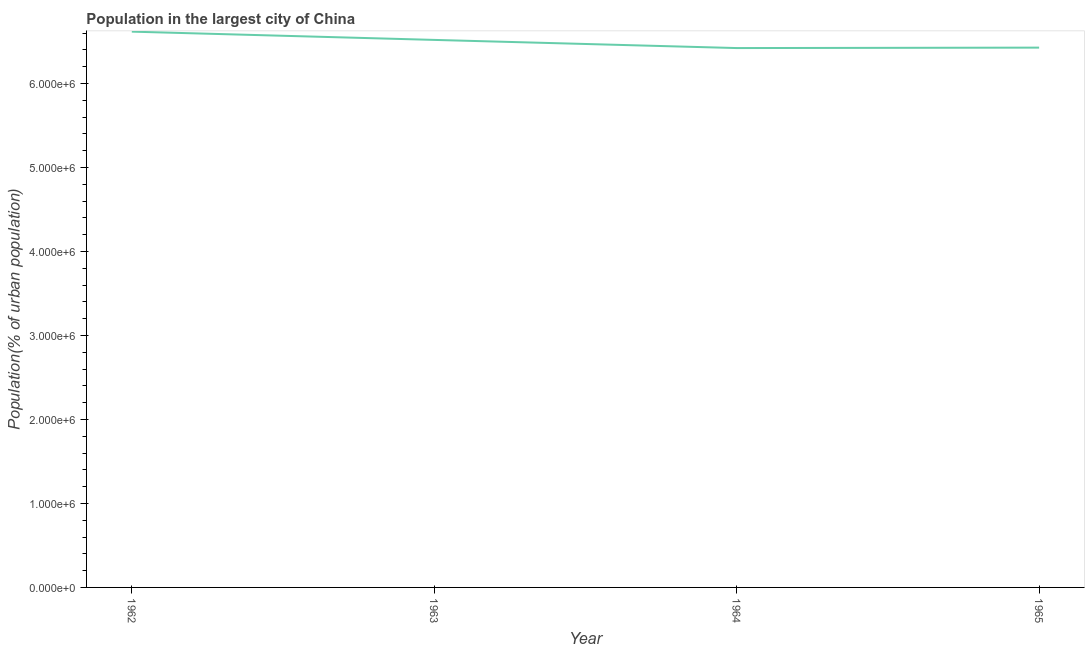What is the population in largest city in 1964?
Your response must be concise. 6.42e+06. Across all years, what is the maximum population in largest city?
Ensure brevity in your answer.  6.62e+06. Across all years, what is the minimum population in largest city?
Your response must be concise. 6.42e+06. In which year was the population in largest city minimum?
Your answer should be compact. 1964. What is the sum of the population in largest city?
Ensure brevity in your answer.  2.60e+07. What is the difference between the population in largest city in 1962 and 1963?
Make the answer very short. 9.84e+04. What is the average population in largest city per year?
Provide a succinct answer. 6.50e+06. What is the median population in largest city?
Ensure brevity in your answer.  6.47e+06. What is the ratio of the population in largest city in 1963 to that in 1965?
Ensure brevity in your answer.  1.01. Is the population in largest city in 1962 less than that in 1963?
Offer a terse response. No. Is the difference between the population in largest city in 1963 and 1964 greater than the difference between any two years?
Provide a succinct answer. No. What is the difference between the highest and the second highest population in largest city?
Offer a terse response. 9.84e+04. What is the difference between the highest and the lowest population in largest city?
Provide a succinct answer. 1.95e+05. In how many years, is the population in largest city greater than the average population in largest city taken over all years?
Offer a terse response. 2. How many lines are there?
Give a very brief answer. 1. How many years are there in the graph?
Provide a short and direct response. 4. What is the title of the graph?
Your answer should be very brief. Population in the largest city of China. What is the label or title of the X-axis?
Your answer should be very brief. Year. What is the label or title of the Y-axis?
Keep it short and to the point. Population(% of urban population). What is the Population(% of urban population) of 1962?
Your response must be concise. 6.62e+06. What is the Population(% of urban population) of 1963?
Give a very brief answer. 6.52e+06. What is the Population(% of urban population) in 1964?
Your answer should be very brief. 6.42e+06. What is the Population(% of urban population) of 1965?
Keep it short and to the point. 6.43e+06. What is the difference between the Population(% of urban population) in 1962 and 1963?
Your answer should be very brief. 9.84e+04. What is the difference between the Population(% of urban population) in 1962 and 1964?
Keep it short and to the point. 1.95e+05. What is the difference between the Population(% of urban population) in 1962 and 1965?
Provide a short and direct response. 1.90e+05. What is the difference between the Population(% of urban population) in 1963 and 1964?
Offer a terse response. 9.71e+04. What is the difference between the Population(% of urban population) in 1963 and 1965?
Your answer should be very brief. 9.20e+04. What is the difference between the Population(% of urban population) in 1964 and 1965?
Provide a succinct answer. -5114. What is the ratio of the Population(% of urban population) in 1962 to that in 1963?
Keep it short and to the point. 1.01. What is the ratio of the Population(% of urban population) in 1962 to that in 1964?
Ensure brevity in your answer.  1.03. What is the ratio of the Population(% of urban population) in 1962 to that in 1965?
Offer a very short reply. 1.03. 